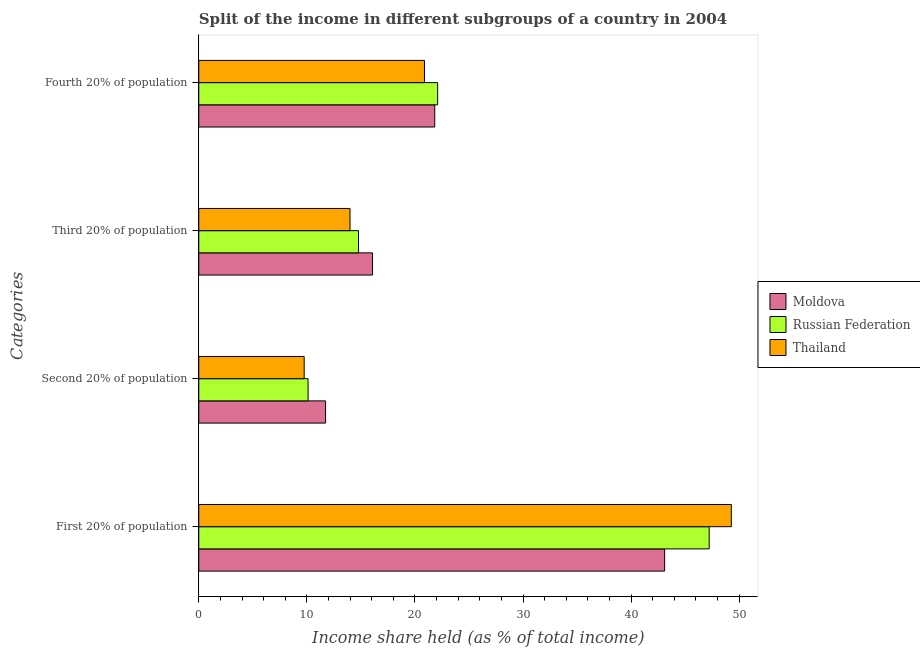How many groups of bars are there?
Your response must be concise. 4. How many bars are there on the 4th tick from the top?
Make the answer very short. 3. How many bars are there on the 2nd tick from the bottom?
Your answer should be very brief. 3. What is the label of the 2nd group of bars from the top?
Your answer should be compact. Third 20% of population. What is the share of the income held by fourth 20% of the population in Moldova?
Give a very brief answer. 21.83. Across all countries, what is the maximum share of the income held by second 20% of the population?
Offer a terse response. 11.73. Across all countries, what is the minimum share of the income held by fourth 20% of the population?
Your response must be concise. 20.88. In which country was the share of the income held by third 20% of the population maximum?
Keep it short and to the point. Moldova. In which country was the share of the income held by second 20% of the population minimum?
Your response must be concise. Thailand. What is the total share of the income held by third 20% of the population in the graph?
Your answer should be compact. 44.84. What is the difference between the share of the income held by second 20% of the population in Thailand and that in Moldova?
Your answer should be compact. -1.98. What is the difference between the share of the income held by fourth 20% of the population in Russian Federation and the share of the income held by third 20% of the population in Moldova?
Keep it short and to the point. 6.03. What is the average share of the income held by first 20% of the population per country?
Your answer should be compact. 46.53. What is the difference between the share of the income held by third 20% of the population and share of the income held by second 20% of the population in Russian Federation?
Give a very brief answer. 4.67. What is the ratio of the share of the income held by fourth 20% of the population in Thailand to that in Russian Federation?
Your response must be concise. 0.94. Is the share of the income held by third 20% of the population in Thailand less than that in Russian Federation?
Make the answer very short. Yes. What is the difference between the highest and the second highest share of the income held by second 20% of the population?
Make the answer very short. 1.62. What is the difference between the highest and the lowest share of the income held by fourth 20% of the population?
Provide a succinct answer. 1.22. Is the sum of the share of the income held by first 20% of the population in Russian Federation and Thailand greater than the maximum share of the income held by third 20% of the population across all countries?
Make the answer very short. Yes. What does the 1st bar from the top in Fourth 20% of population represents?
Your response must be concise. Thailand. What does the 3rd bar from the bottom in Third 20% of population represents?
Ensure brevity in your answer.  Thailand. How many bars are there?
Your response must be concise. 12. Are all the bars in the graph horizontal?
Your answer should be very brief. Yes. What is the difference between two consecutive major ticks on the X-axis?
Your answer should be very brief. 10. Are the values on the major ticks of X-axis written in scientific E-notation?
Offer a terse response. No. Does the graph contain any zero values?
Offer a very short reply. No. Where does the legend appear in the graph?
Offer a very short reply. Center right. How many legend labels are there?
Make the answer very short. 3. How are the legend labels stacked?
Ensure brevity in your answer.  Vertical. What is the title of the graph?
Your answer should be compact. Split of the income in different subgroups of a country in 2004. What is the label or title of the X-axis?
Offer a terse response. Income share held (as % of total income). What is the label or title of the Y-axis?
Your answer should be very brief. Categories. What is the Income share held (as % of total income) of Moldova in First 20% of population?
Offer a terse response. 43.1. What is the Income share held (as % of total income) in Russian Federation in First 20% of population?
Ensure brevity in your answer.  47.22. What is the Income share held (as % of total income) of Thailand in First 20% of population?
Provide a succinct answer. 49.27. What is the Income share held (as % of total income) in Moldova in Second 20% of population?
Provide a short and direct response. 11.73. What is the Income share held (as % of total income) in Russian Federation in Second 20% of population?
Make the answer very short. 10.11. What is the Income share held (as % of total income) in Thailand in Second 20% of population?
Offer a very short reply. 9.75. What is the Income share held (as % of total income) of Moldova in Third 20% of population?
Your answer should be compact. 16.07. What is the Income share held (as % of total income) of Russian Federation in Third 20% of population?
Offer a terse response. 14.78. What is the Income share held (as % of total income) of Thailand in Third 20% of population?
Your answer should be very brief. 13.99. What is the Income share held (as % of total income) of Moldova in Fourth 20% of population?
Offer a very short reply. 21.83. What is the Income share held (as % of total income) in Russian Federation in Fourth 20% of population?
Provide a succinct answer. 22.1. What is the Income share held (as % of total income) of Thailand in Fourth 20% of population?
Make the answer very short. 20.88. Across all Categories, what is the maximum Income share held (as % of total income) in Moldova?
Keep it short and to the point. 43.1. Across all Categories, what is the maximum Income share held (as % of total income) in Russian Federation?
Make the answer very short. 47.22. Across all Categories, what is the maximum Income share held (as % of total income) of Thailand?
Provide a short and direct response. 49.27. Across all Categories, what is the minimum Income share held (as % of total income) of Moldova?
Your response must be concise. 11.73. Across all Categories, what is the minimum Income share held (as % of total income) of Russian Federation?
Offer a terse response. 10.11. Across all Categories, what is the minimum Income share held (as % of total income) of Thailand?
Keep it short and to the point. 9.75. What is the total Income share held (as % of total income) in Moldova in the graph?
Your response must be concise. 92.73. What is the total Income share held (as % of total income) in Russian Federation in the graph?
Offer a terse response. 94.21. What is the total Income share held (as % of total income) in Thailand in the graph?
Give a very brief answer. 93.89. What is the difference between the Income share held (as % of total income) in Moldova in First 20% of population and that in Second 20% of population?
Make the answer very short. 31.37. What is the difference between the Income share held (as % of total income) of Russian Federation in First 20% of population and that in Second 20% of population?
Your answer should be very brief. 37.11. What is the difference between the Income share held (as % of total income) in Thailand in First 20% of population and that in Second 20% of population?
Offer a very short reply. 39.52. What is the difference between the Income share held (as % of total income) in Moldova in First 20% of population and that in Third 20% of population?
Provide a succinct answer. 27.03. What is the difference between the Income share held (as % of total income) in Russian Federation in First 20% of population and that in Third 20% of population?
Provide a short and direct response. 32.44. What is the difference between the Income share held (as % of total income) of Thailand in First 20% of population and that in Third 20% of population?
Provide a short and direct response. 35.28. What is the difference between the Income share held (as % of total income) of Moldova in First 20% of population and that in Fourth 20% of population?
Give a very brief answer. 21.27. What is the difference between the Income share held (as % of total income) of Russian Federation in First 20% of population and that in Fourth 20% of population?
Provide a succinct answer. 25.12. What is the difference between the Income share held (as % of total income) in Thailand in First 20% of population and that in Fourth 20% of population?
Your answer should be compact. 28.39. What is the difference between the Income share held (as % of total income) of Moldova in Second 20% of population and that in Third 20% of population?
Your response must be concise. -4.34. What is the difference between the Income share held (as % of total income) of Russian Federation in Second 20% of population and that in Third 20% of population?
Provide a short and direct response. -4.67. What is the difference between the Income share held (as % of total income) of Thailand in Second 20% of population and that in Third 20% of population?
Your response must be concise. -4.24. What is the difference between the Income share held (as % of total income) of Russian Federation in Second 20% of population and that in Fourth 20% of population?
Ensure brevity in your answer.  -11.99. What is the difference between the Income share held (as % of total income) in Thailand in Second 20% of population and that in Fourth 20% of population?
Make the answer very short. -11.13. What is the difference between the Income share held (as % of total income) of Moldova in Third 20% of population and that in Fourth 20% of population?
Ensure brevity in your answer.  -5.76. What is the difference between the Income share held (as % of total income) in Russian Federation in Third 20% of population and that in Fourth 20% of population?
Your answer should be very brief. -7.32. What is the difference between the Income share held (as % of total income) of Thailand in Third 20% of population and that in Fourth 20% of population?
Keep it short and to the point. -6.89. What is the difference between the Income share held (as % of total income) of Moldova in First 20% of population and the Income share held (as % of total income) of Russian Federation in Second 20% of population?
Offer a terse response. 32.99. What is the difference between the Income share held (as % of total income) of Moldova in First 20% of population and the Income share held (as % of total income) of Thailand in Second 20% of population?
Offer a very short reply. 33.35. What is the difference between the Income share held (as % of total income) in Russian Federation in First 20% of population and the Income share held (as % of total income) in Thailand in Second 20% of population?
Give a very brief answer. 37.47. What is the difference between the Income share held (as % of total income) of Moldova in First 20% of population and the Income share held (as % of total income) of Russian Federation in Third 20% of population?
Your answer should be very brief. 28.32. What is the difference between the Income share held (as % of total income) in Moldova in First 20% of population and the Income share held (as % of total income) in Thailand in Third 20% of population?
Offer a terse response. 29.11. What is the difference between the Income share held (as % of total income) of Russian Federation in First 20% of population and the Income share held (as % of total income) of Thailand in Third 20% of population?
Your answer should be compact. 33.23. What is the difference between the Income share held (as % of total income) in Moldova in First 20% of population and the Income share held (as % of total income) in Thailand in Fourth 20% of population?
Ensure brevity in your answer.  22.22. What is the difference between the Income share held (as % of total income) of Russian Federation in First 20% of population and the Income share held (as % of total income) of Thailand in Fourth 20% of population?
Keep it short and to the point. 26.34. What is the difference between the Income share held (as % of total income) of Moldova in Second 20% of population and the Income share held (as % of total income) of Russian Federation in Third 20% of population?
Keep it short and to the point. -3.05. What is the difference between the Income share held (as % of total income) in Moldova in Second 20% of population and the Income share held (as % of total income) in Thailand in Third 20% of population?
Provide a short and direct response. -2.26. What is the difference between the Income share held (as % of total income) in Russian Federation in Second 20% of population and the Income share held (as % of total income) in Thailand in Third 20% of population?
Your answer should be very brief. -3.88. What is the difference between the Income share held (as % of total income) of Moldova in Second 20% of population and the Income share held (as % of total income) of Russian Federation in Fourth 20% of population?
Provide a short and direct response. -10.37. What is the difference between the Income share held (as % of total income) in Moldova in Second 20% of population and the Income share held (as % of total income) in Thailand in Fourth 20% of population?
Offer a very short reply. -9.15. What is the difference between the Income share held (as % of total income) in Russian Federation in Second 20% of population and the Income share held (as % of total income) in Thailand in Fourth 20% of population?
Your response must be concise. -10.77. What is the difference between the Income share held (as % of total income) of Moldova in Third 20% of population and the Income share held (as % of total income) of Russian Federation in Fourth 20% of population?
Give a very brief answer. -6.03. What is the difference between the Income share held (as % of total income) in Moldova in Third 20% of population and the Income share held (as % of total income) in Thailand in Fourth 20% of population?
Your response must be concise. -4.81. What is the average Income share held (as % of total income) of Moldova per Categories?
Your answer should be very brief. 23.18. What is the average Income share held (as % of total income) of Russian Federation per Categories?
Your answer should be compact. 23.55. What is the average Income share held (as % of total income) in Thailand per Categories?
Keep it short and to the point. 23.47. What is the difference between the Income share held (as % of total income) of Moldova and Income share held (as % of total income) of Russian Federation in First 20% of population?
Offer a terse response. -4.12. What is the difference between the Income share held (as % of total income) of Moldova and Income share held (as % of total income) of Thailand in First 20% of population?
Give a very brief answer. -6.17. What is the difference between the Income share held (as % of total income) of Russian Federation and Income share held (as % of total income) of Thailand in First 20% of population?
Provide a short and direct response. -2.05. What is the difference between the Income share held (as % of total income) in Moldova and Income share held (as % of total income) in Russian Federation in Second 20% of population?
Ensure brevity in your answer.  1.62. What is the difference between the Income share held (as % of total income) of Moldova and Income share held (as % of total income) of Thailand in Second 20% of population?
Keep it short and to the point. 1.98. What is the difference between the Income share held (as % of total income) in Russian Federation and Income share held (as % of total income) in Thailand in Second 20% of population?
Offer a very short reply. 0.36. What is the difference between the Income share held (as % of total income) of Moldova and Income share held (as % of total income) of Russian Federation in Third 20% of population?
Provide a succinct answer. 1.29. What is the difference between the Income share held (as % of total income) of Moldova and Income share held (as % of total income) of Thailand in Third 20% of population?
Your response must be concise. 2.08. What is the difference between the Income share held (as % of total income) of Russian Federation and Income share held (as % of total income) of Thailand in Third 20% of population?
Make the answer very short. 0.79. What is the difference between the Income share held (as % of total income) of Moldova and Income share held (as % of total income) of Russian Federation in Fourth 20% of population?
Offer a very short reply. -0.27. What is the difference between the Income share held (as % of total income) of Russian Federation and Income share held (as % of total income) of Thailand in Fourth 20% of population?
Your answer should be compact. 1.22. What is the ratio of the Income share held (as % of total income) in Moldova in First 20% of population to that in Second 20% of population?
Your answer should be compact. 3.67. What is the ratio of the Income share held (as % of total income) in Russian Federation in First 20% of population to that in Second 20% of population?
Your answer should be compact. 4.67. What is the ratio of the Income share held (as % of total income) of Thailand in First 20% of population to that in Second 20% of population?
Provide a short and direct response. 5.05. What is the ratio of the Income share held (as % of total income) of Moldova in First 20% of population to that in Third 20% of population?
Ensure brevity in your answer.  2.68. What is the ratio of the Income share held (as % of total income) of Russian Federation in First 20% of population to that in Third 20% of population?
Your answer should be very brief. 3.19. What is the ratio of the Income share held (as % of total income) of Thailand in First 20% of population to that in Third 20% of population?
Offer a terse response. 3.52. What is the ratio of the Income share held (as % of total income) of Moldova in First 20% of population to that in Fourth 20% of population?
Make the answer very short. 1.97. What is the ratio of the Income share held (as % of total income) in Russian Federation in First 20% of population to that in Fourth 20% of population?
Offer a very short reply. 2.14. What is the ratio of the Income share held (as % of total income) of Thailand in First 20% of population to that in Fourth 20% of population?
Ensure brevity in your answer.  2.36. What is the ratio of the Income share held (as % of total income) of Moldova in Second 20% of population to that in Third 20% of population?
Make the answer very short. 0.73. What is the ratio of the Income share held (as % of total income) of Russian Federation in Second 20% of population to that in Third 20% of population?
Your answer should be compact. 0.68. What is the ratio of the Income share held (as % of total income) of Thailand in Second 20% of population to that in Third 20% of population?
Make the answer very short. 0.7. What is the ratio of the Income share held (as % of total income) of Moldova in Second 20% of population to that in Fourth 20% of population?
Provide a succinct answer. 0.54. What is the ratio of the Income share held (as % of total income) of Russian Federation in Second 20% of population to that in Fourth 20% of population?
Your response must be concise. 0.46. What is the ratio of the Income share held (as % of total income) in Thailand in Second 20% of population to that in Fourth 20% of population?
Provide a succinct answer. 0.47. What is the ratio of the Income share held (as % of total income) of Moldova in Third 20% of population to that in Fourth 20% of population?
Keep it short and to the point. 0.74. What is the ratio of the Income share held (as % of total income) in Russian Federation in Third 20% of population to that in Fourth 20% of population?
Make the answer very short. 0.67. What is the ratio of the Income share held (as % of total income) in Thailand in Third 20% of population to that in Fourth 20% of population?
Ensure brevity in your answer.  0.67. What is the difference between the highest and the second highest Income share held (as % of total income) of Moldova?
Keep it short and to the point. 21.27. What is the difference between the highest and the second highest Income share held (as % of total income) in Russian Federation?
Keep it short and to the point. 25.12. What is the difference between the highest and the second highest Income share held (as % of total income) of Thailand?
Your answer should be compact. 28.39. What is the difference between the highest and the lowest Income share held (as % of total income) of Moldova?
Give a very brief answer. 31.37. What is the difference between the highest and the lowest Income share held (as % of total income) in Russian Federation?
Make the answer very short. 37.11. What is the difference between the highest and the lowest Income share held (as % of total income) of Thailand?
Give a very brief answer. 39.52. 